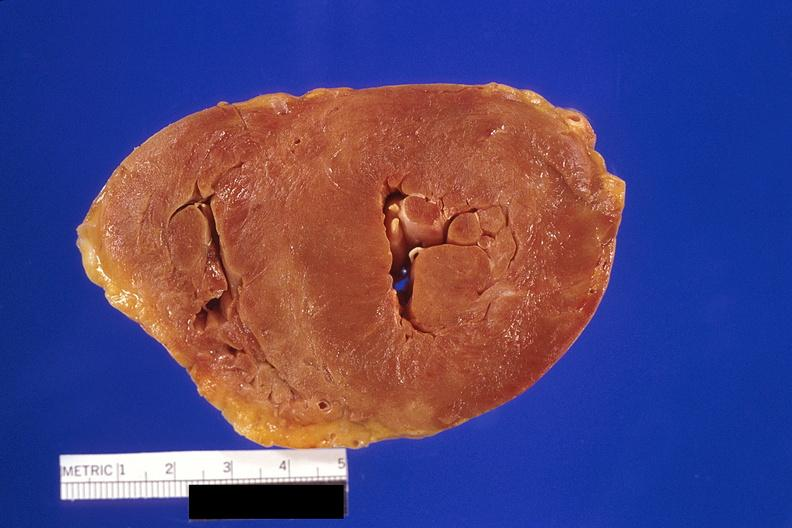s abdomen present?
Answer the question using a single word or phrase. No 